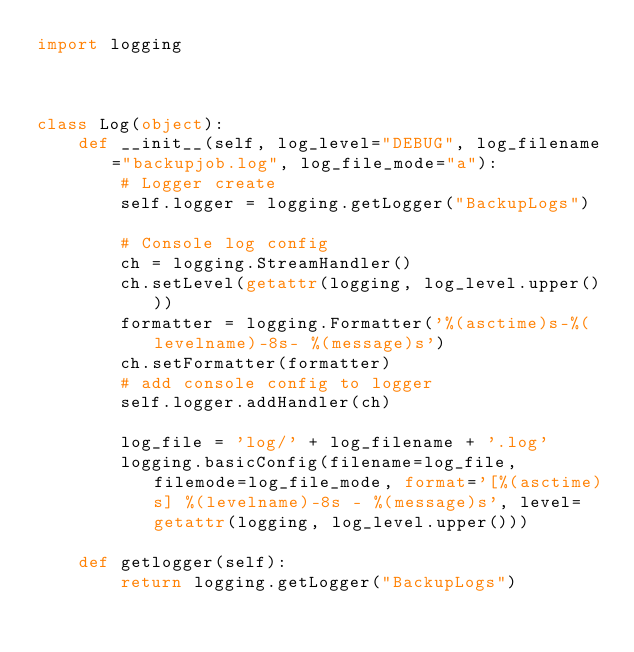Convert code to text. <code><loc_0><loc_0><loc_500><loc_500><_Python_>import logging



class Log(object):
    def __init__(self, log_level="DEBUG", log_filename="backupjob.log", log_file_mode="a"):
        # Logger create
        self.logger = logging.getLogger("BackupLogs")

        # Console log config
        ch = logging.StreamHandler()
        ch.setLevel(getattr(logging, log_level.upper()))
        formatter = logging.Formatter('%(asctime)s-%(levelname)-8s- %(message)s')
        ch.setFormatter(formatter)
        # add console config to logger
        self.logger.addHandler(ch)

        log_file = 'log/' + log_filename + '.log'
        logging.basicConfig(filename=log_file, filemode=log_file_mode, format='[%(asctime)s] %(levelname)-8s - %(message)s', level=getattr(logging, log_level.upper()))

    def getlogger(self):
        return logging.getLogger("BackupLogs")
</code> 